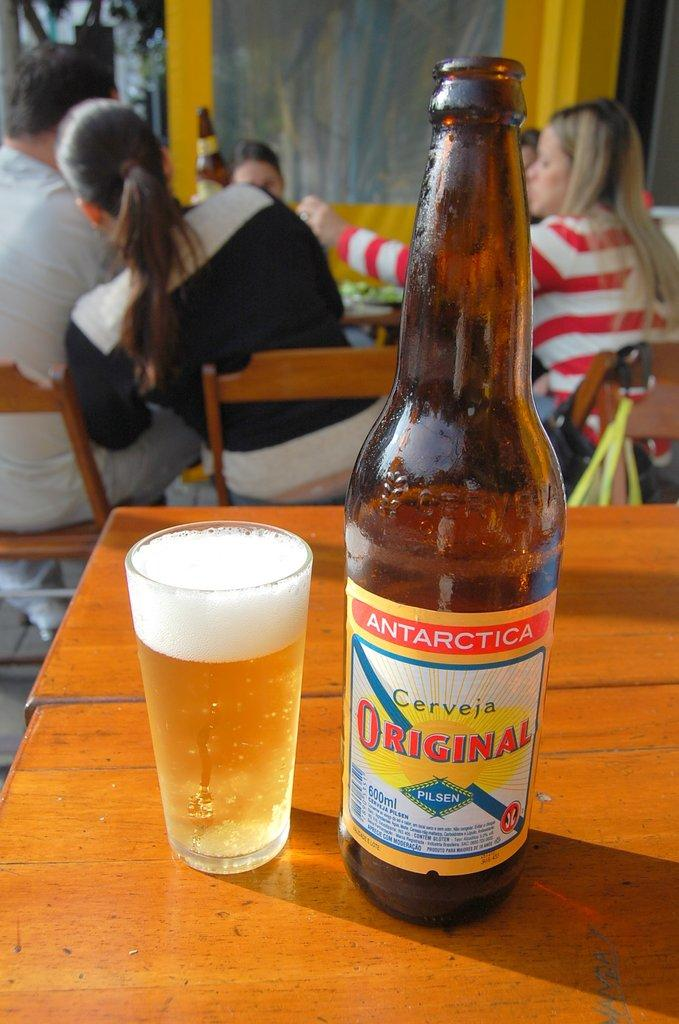<image>
Provide a brief description of the given image. A tiny glass of beer stands next to a bottle of Antarctica. 